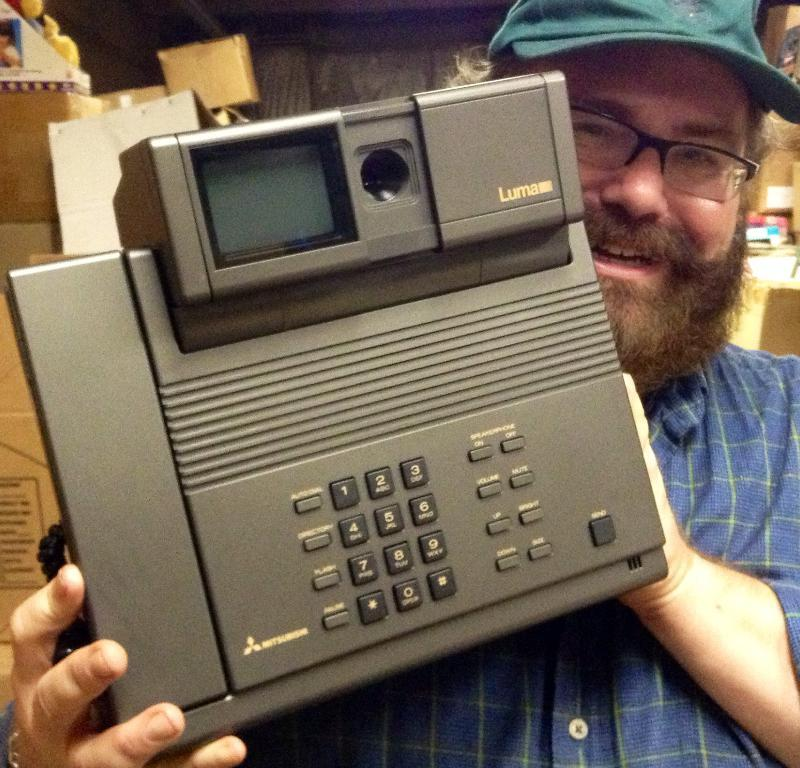Who is present in the image? There is a man in the image. What is the man holding in the image? The man is holding a telephone. What can be seen in the background of the image? There are boxes and a wall in the background of the image. Can you see a toad sitting on the chair in the image? There is no chair or toad present in the image. 